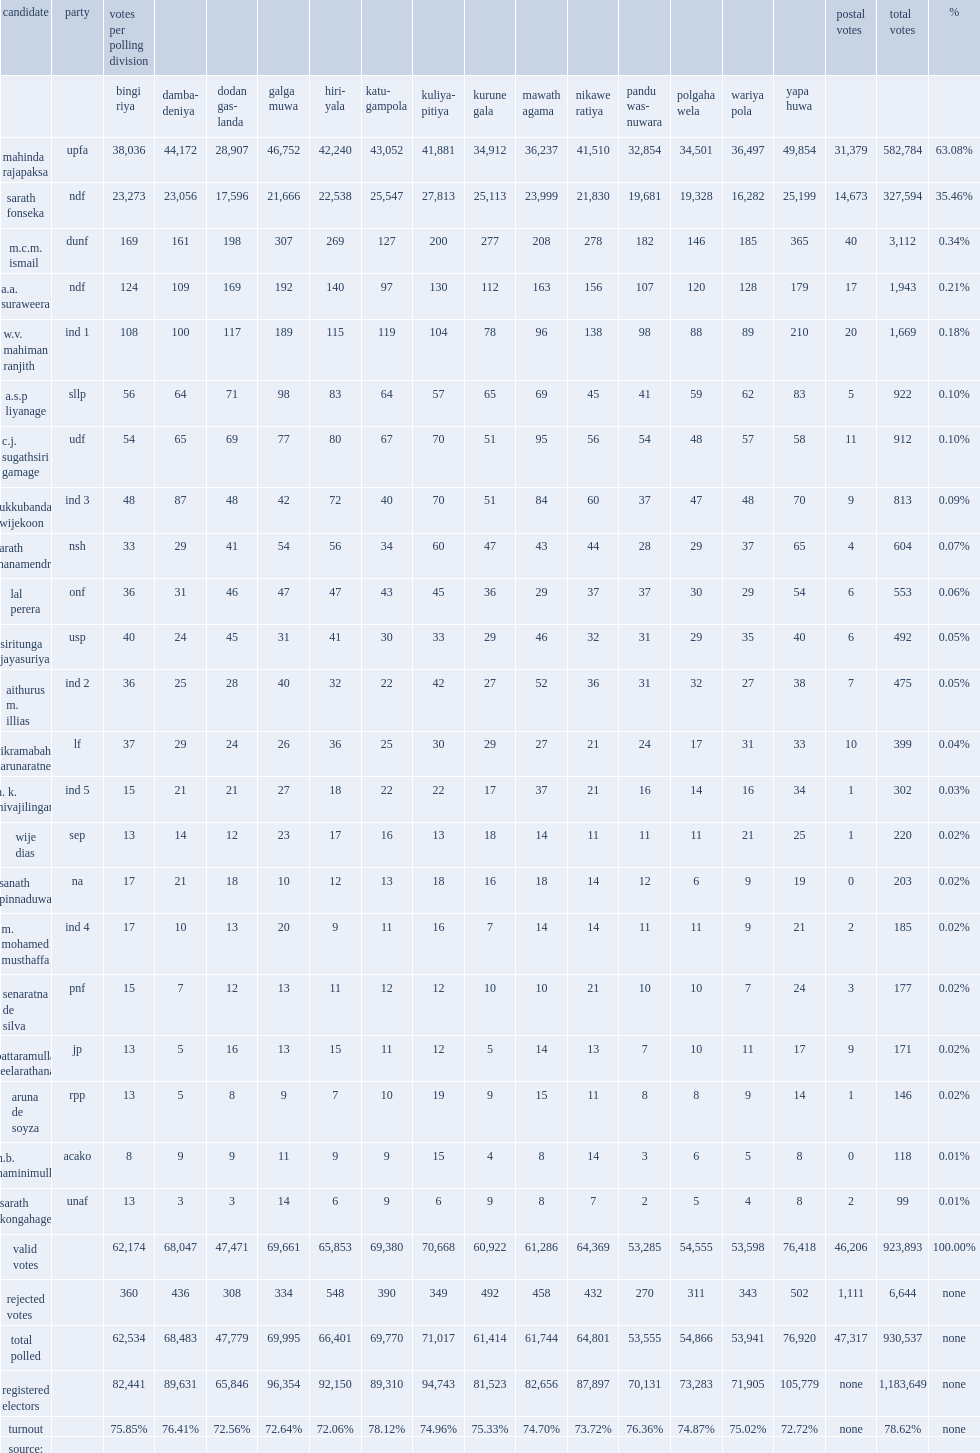How many registered electors are in the kurunegala district in 2010? 1183649.0. 